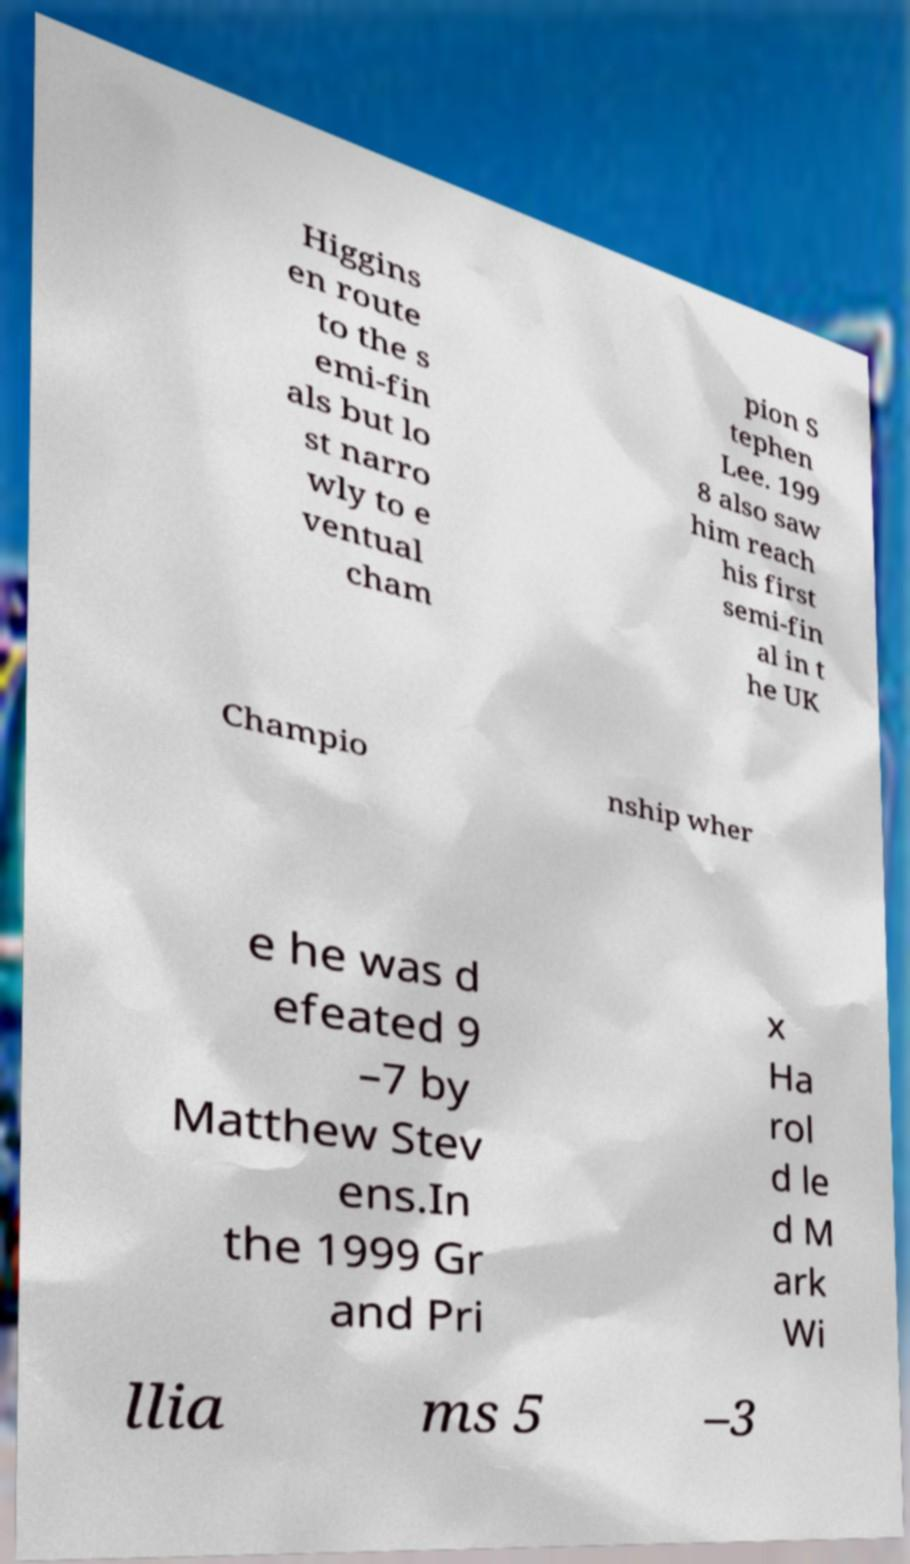There's text embedded in this image that I need extracted. Can you transcribe it verbatim? Higgins en route to the s emi-fin als but lo st narro wly to e ventual cham pion S tephen Lee. 199 8 also saw him reach his first semi-fin al in t he UK Champio nship wher e he was d efeated 9 –7 by Matthew Stev ens.In the 1999 Gr and Pri x Ha rol d le d M ark Wi llia ms 5 –3 